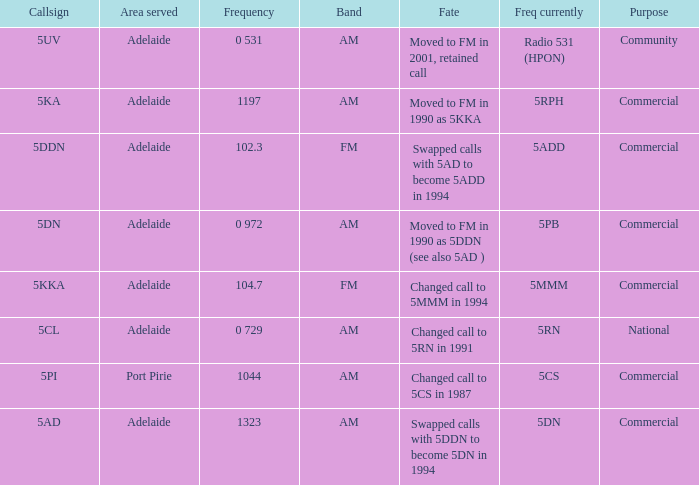What is the purpose for Frequency of 102.3? Commercial. 